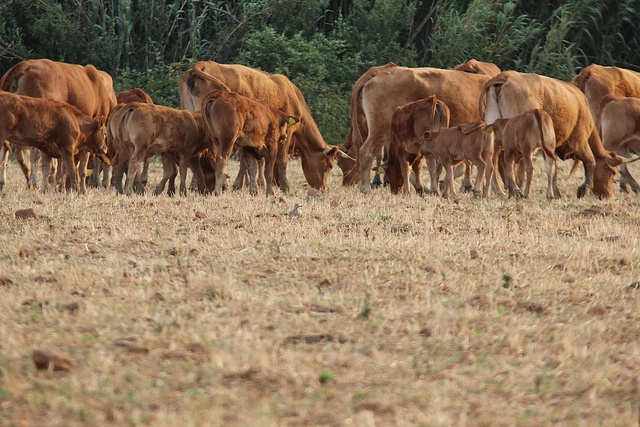Describe the objects in this image and their specific colors. I can see cow in black, gray, tan, maroon, and brown tones, cow in black, brown, gray, and maroon tones, cow in black, gray, maroon, tan, and brown tones, cow in black, maroon, brown, and gray tones, and cow in black, maroon, and brown tones in this image. 